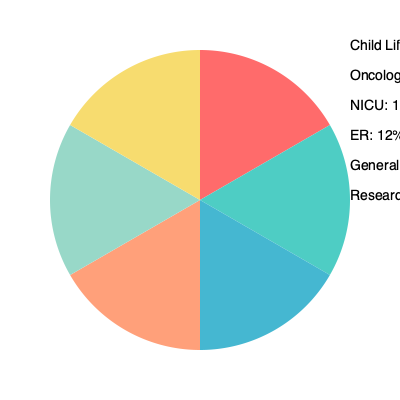Based on the pie chart showing the distribution of funds raised for different hospital departments, what percentage of the total funds raised would be allocated to support programs directly benefiting pediatric patients in critical care units? To answer this question, we need to identify the departments that directly benefit pediatric patients in critical care units and sum their percentages. Let's break it down step-by-step:

1. Identify relevant departments:
   - NICU (Neonatal Intensive Care Unit): 15%
   - ER (Emergency Room): 12%

   Both of these departments are critical care units that serve pediatric patients.

2. Sum the percentages:
   $15\% + 12\% = 27\%$

3. Consider other potentially relevant departments:
   - Child Life: 30%
   While Child Life programs benefit all pediatric patients, including those in critical care, they are not exclusively for critical care units. However, as a supporter of the Child Life program, you might consider including this in your calculation.

4. Final calculation:
   If we include Child Life: $27\% + 30\% = 57\%$
   If we focus strictly on critical care units: $27\%$

Given that the question specifically asks about "critical care units," we should use the more conservative estimate of 27%.
Answer: 27% 